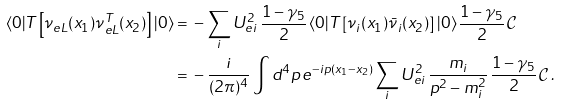Convert formula to latex. <formula><loc_0><loc_0><loc_500><loc_500>\langle 0 | T \left [ \nu _ { e L } ( x _ { 1 } ) \nu ^ { T } _ { e L } ( x _ { 2 } ) \right ] | 0 \rangle = \null & \null - \sum _ { i } U _ { e i } ^ { 2 } \, \frac { 1 - \gamma _ { 5 } } { 2 } \, \langle 0 | T \left [ \nu _ { i } ( x _ { 1 } ) \bar { \nu } _ { i } ( x _ { 2 } ) \right ] | 0 \rangle \, \frac { 1 - \gamma _ { 5 } } { 2 } \, \mathcal { C } \\ = \null & \null - \frac { i } { ( 2 \pi ) ^ { 4 } } \int d ^ { 4 } p \, e ^ { - i p ( x _ { 1 } - x _ { 2 } ) } \sum _ { i } U ^ { 2 } _ { e i } \, \frac { m _ { i } } { p ^ { 2 } - m ^ { 2 } _ { i } } \, \frac { 1 - \gamma _ { 5 } } { 2 } \, \mathcal { C } \, .</formula> 